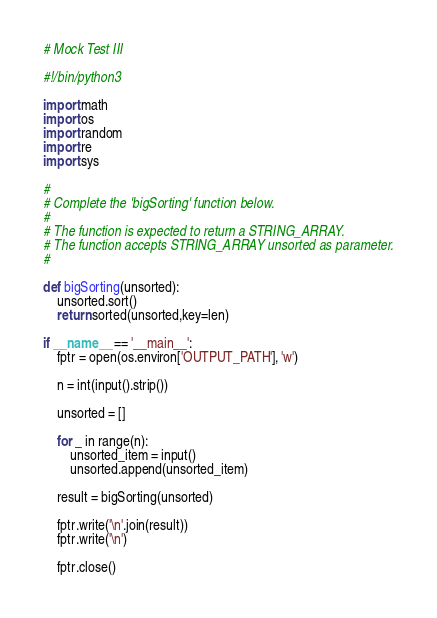<code> <loc_0><loc_0><loc_500><loc_500><_Python_># Mock Test III

#!/bin/python3

import math
import os
import random
import re
import sys

#
# Complete the 'bigSorting' function below.
#
# The function is expected to return a STRING_ARRAY.
# The function accepts STRING_ARRAY unsorted as parameter.
#

def bigSorting(unsorted):
    unsorted.sort()
    return sorted(unsorted,key=len)

if __name__ == '__main__':
    fptr = open(os.environ['OUTPUT_PATH'], 'w')

    n = int(input().strip())

    unsorted = []

    for _ in range(n):
        unsorted_item = input()
        unsorted.append(unsorted_item)

    result = bigSorting(unsorted)

    fptr.write('\n'.join(result))
    fptr.write('\n')

    fptr.close()</code> 